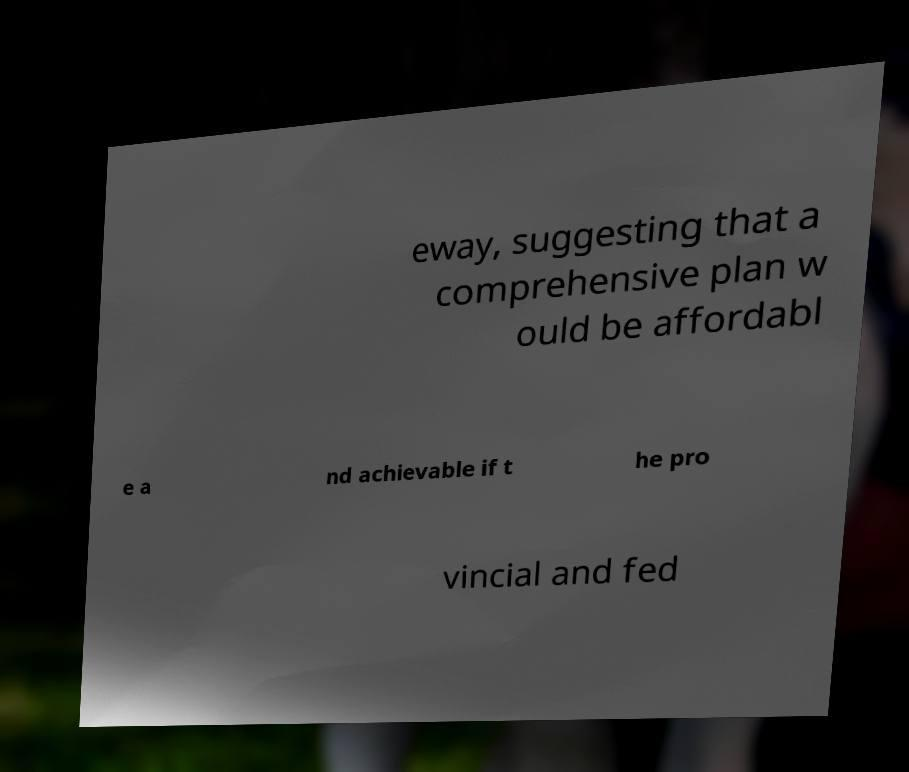I need the written content from this picture converted into text. Can you do that? eway, suggesting that a comprehensive plan w ould be affordabl e a nd achievable if t he pro vincial and fed 